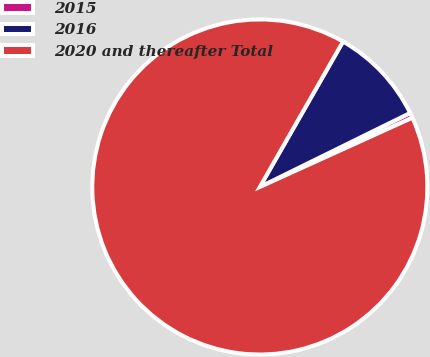Convert chart to OTSL. <chart><loc_0><loc_0><loc_500><loc_500><pie_chart><fcel>2015<fcel>2016<fcel>2020 and thereafter Total<nl><fcel>0.5%<fcel>9.45%<fcel>90.05%<nl></chart> 